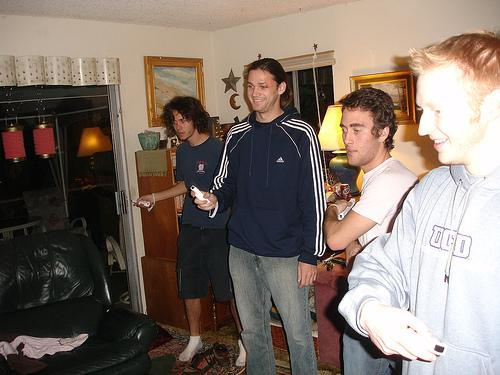Point out a decorative item hanging on the wall alongside the moon. There is a brown star hanging on the wall beside the moon. Identify a piece of artwork that is displayed in the room. There is a painting in a gold frame on the wall. What is the color and style of the lamp captured in the image? The lamp is blue with a tan shade. What type of accessory does the man in the dark blue shirt seem to be using? The man in the dark blue shirt is holding a Nintendo Wii controller. In your own words, narrate the scene captured in the image. Several friends are gathered in a room with various items such as paintings, lamps, and chairs. They are playing video games using Nintendo Wii controllers and having a good time together. How would you describe the atmosphere of the room based on the image? The atmosphere seems relaxed and enjoyable as friends gather to play video games and have a good time. Can you count the number of objects on the floor? There are 4 objects on the floor: 2 pairs of shoes, a pair of white socks, and a pair of blue jeans. Mention one unique characteristic of the man with long brown hair. The man with long brown hair is wearing a white sweater with blue stripes on it. Which object of clothing can you spot in a messy state within the room? A white tee shirt is strewn on the couch, appearing crumpled and disorganized. Can you please describe the appearance of one of the men present in the room? One man has short red hair and is wearing a hoodie with writing on it. 